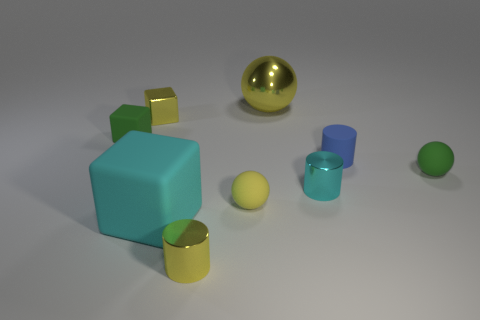Add 1 green spheres. How many objects exist? 10 Subtract all cubes. How many objects are left? 6 Add 2 green rubber things. How many green rubber things are left? 4 Add 8 green rubber blocks. How many green rubber blocks exist? 9 Subtract 0 purple balls. How many objects are left? 9 Subtract all green objects. Subtract all small cyan cylinders. How many objects are left? 6 